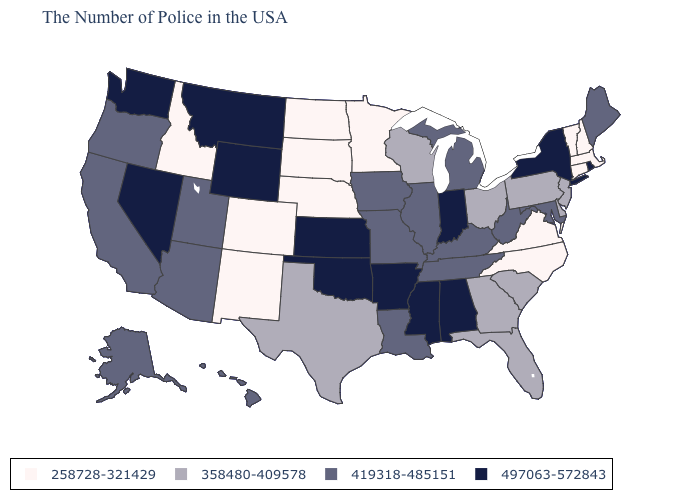Does Nebraska have the lowest value in the USA?
Short answer required. Yes. What is the value of Virginia?
Give a very brief answer. 258728-321429. What is the value of North Carolina?
Write a very short answer. 258728-321429. Does the first symbol in the legend represent the smallest category?
Short answer required. Yes. Which states hav the highest value in the West?
Answer briefly. Wyoming, Montana, Nevada, Washington. What is the value of New York?
Write a very short answer. 497063-572843. Does Nebraska have the highest value in the MidWest?
Answer briefly. No. Does the first symbol in the legend represent the smallest category?
Short answer required. Yes. What is the value of Vermont?
Be succinct. 258728-321429. Which states have the lowest value in the South?
Be succinct. Virginia, North Carolina. Name the states that have a value in the range 419318-485151?
Keep it brief. Maine, Maryland, West Virginia, Michigan, Kentucky, Tennessee, Illinois, Louisiana, Missouri, Iowa, Utah, Arizona, California, Oregon, Alaska, Hawaii. What is the highest value in the USA?
Quick response, please. 497063-572843. What is the lowest value in states that border Oklahoma?
Short answer required. 258728-321429. Does Nebraska have the highest value in the MidWest?
Short answer required. No. Among the states that border Massachusetts , does Connecticut have the highest value?
Write a very short answer. No. 